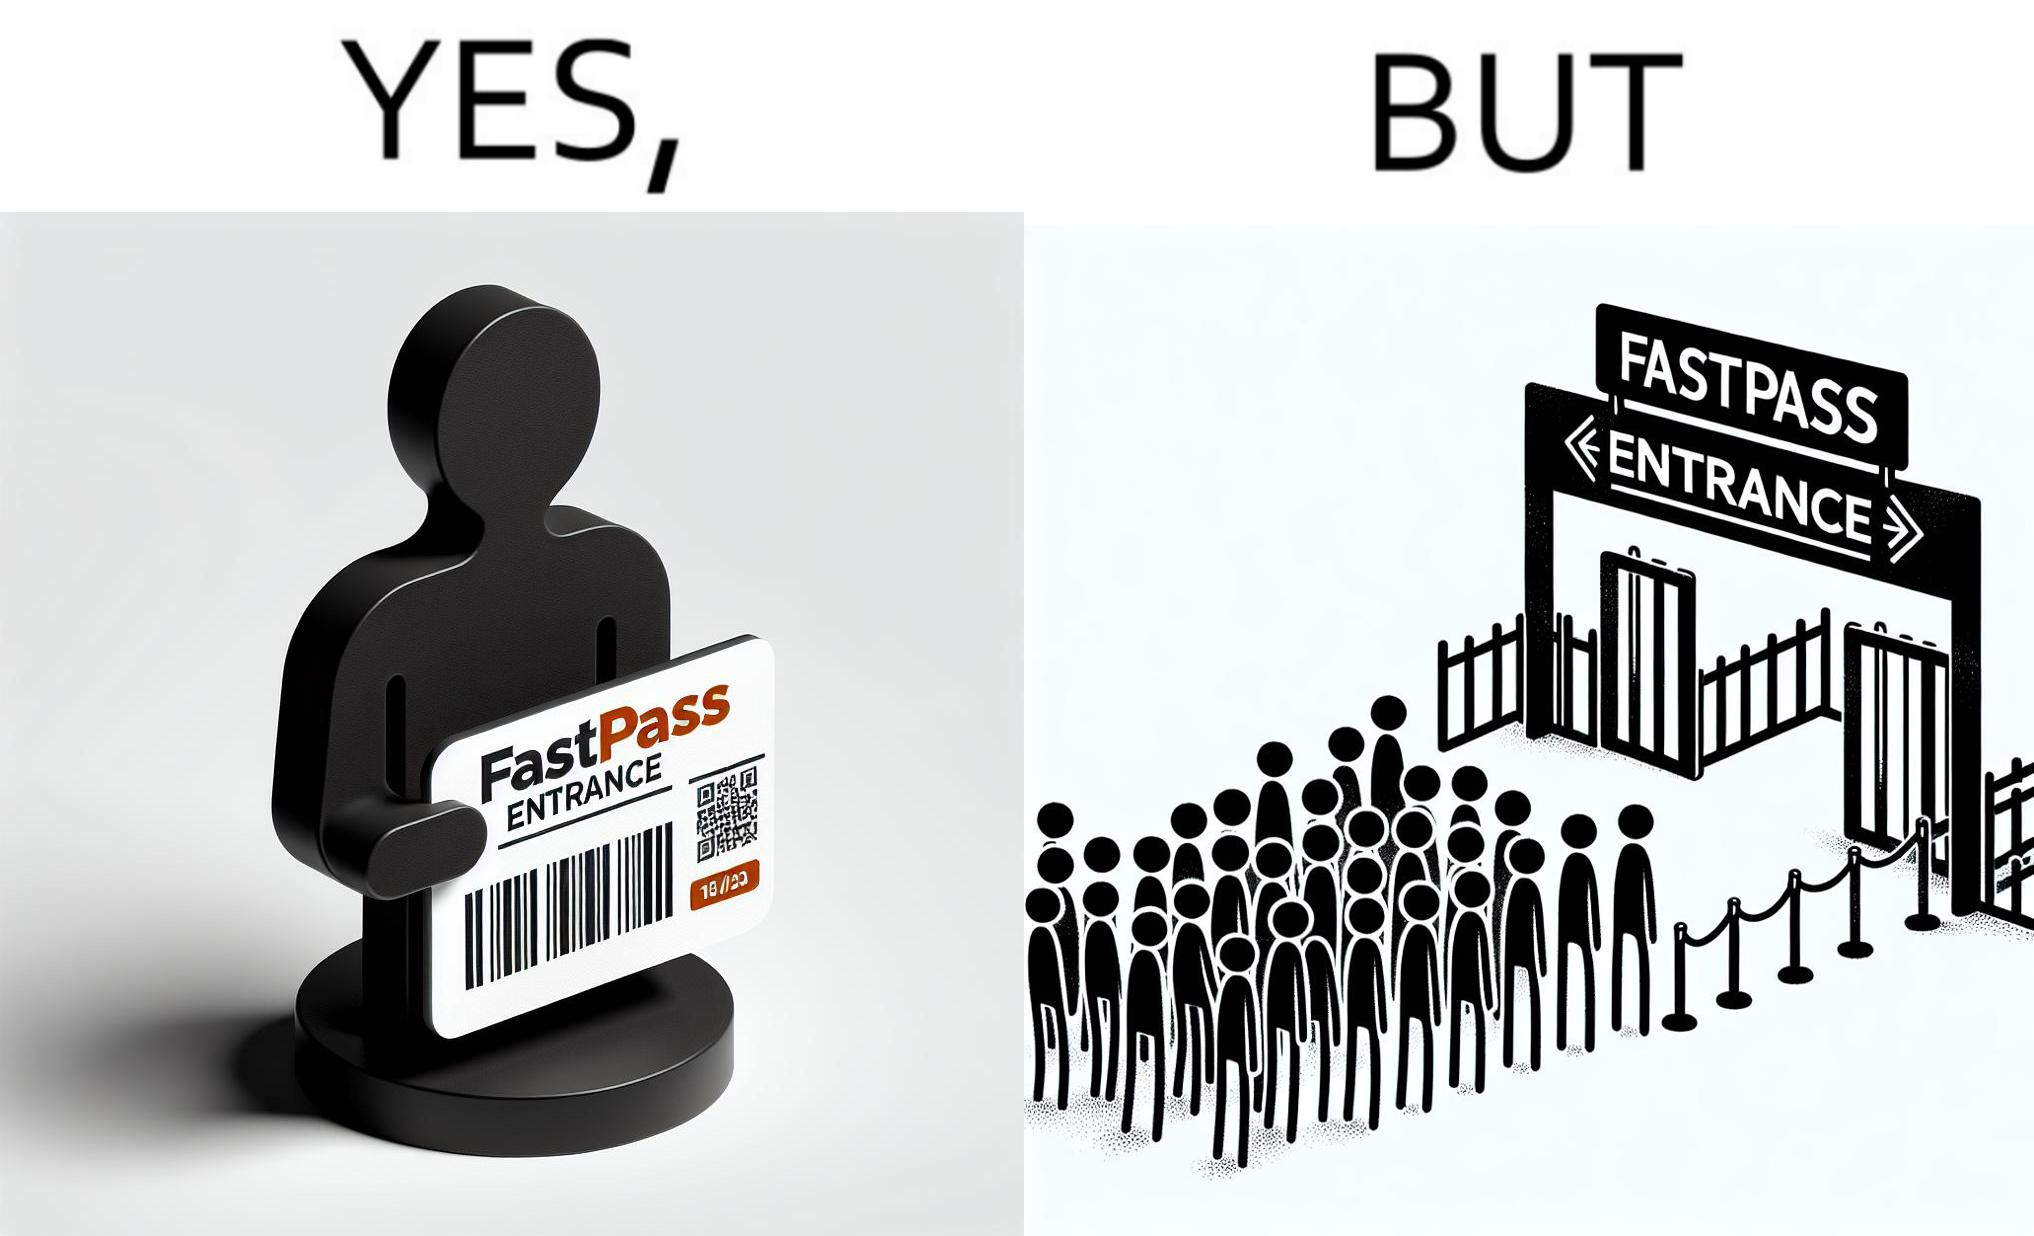Provide a description of this image. The image is ironic, because fast pass entrance was meant for people to pass the gate fast but as more no. of people bought the pass due to which the queue has become longer and it becomes slow and time consuming 